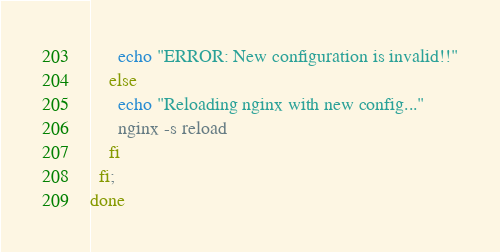Convert code to text. <code><loc_0><loc_0><loc_500><loc_500><_Bash_>      echo "ERROR: New configuration is invalid!!"
    else
      echo "Reloading nginx with new config..."
      nginx -s reload
    fi
  fi;
done
</code> 